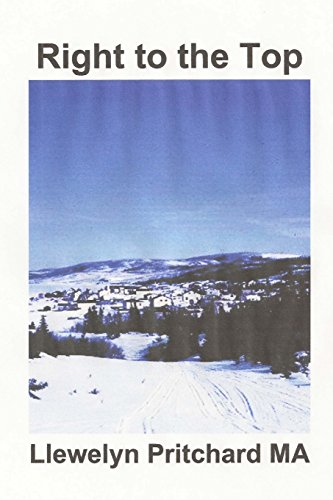Who is the author of this book? The author of the book, as shown on its cover, is 'Llewelyn Pritchard MA'. He is a prolific writer with a focus on travel and historical insights. 